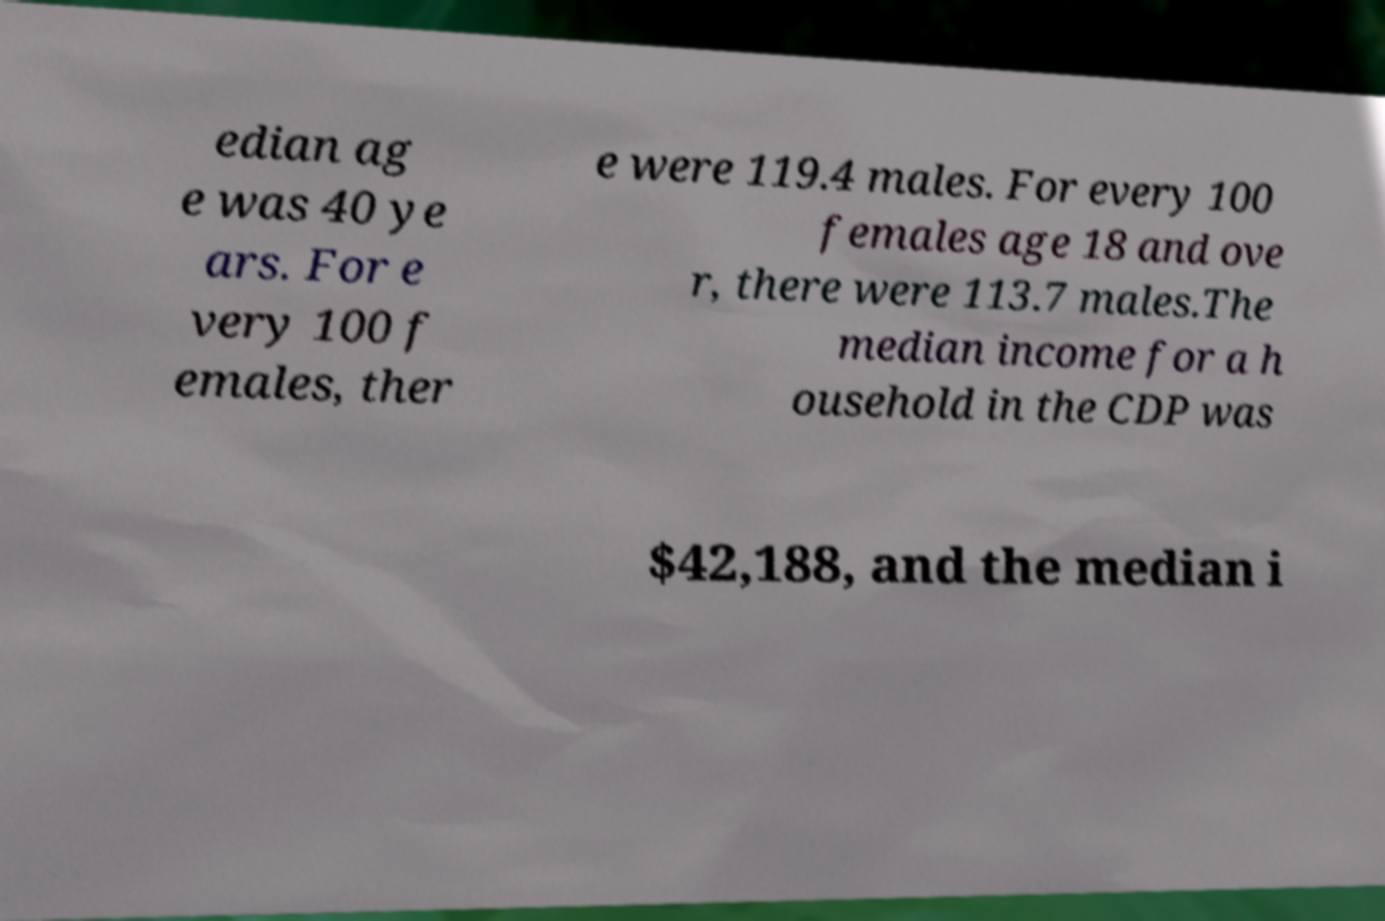Please read and relay the text visible in this image. What does it say? edian ag e was 40 ye ars. For e very 100 f emales, ther e were 119.4 males. For every 100 females age 18 and ove r, there were 113.7 males.The median income for a h ousehold in the CDP was $42,188, and the median i 